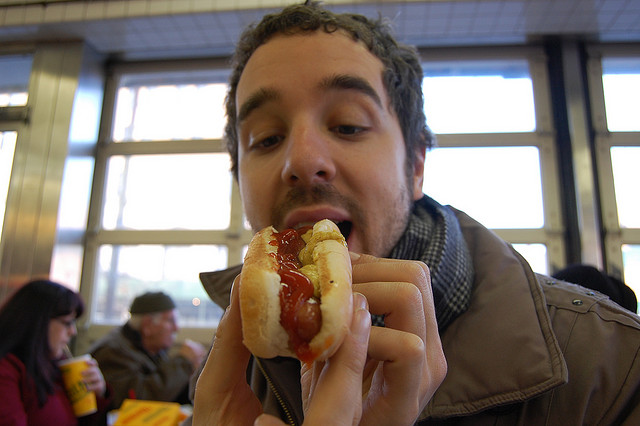How many zebras can you see? Although the question is about spotting zebras, there are no zebras visible in the image. Instead, we see an image of a person enjoying a hot dog with ketchup. 